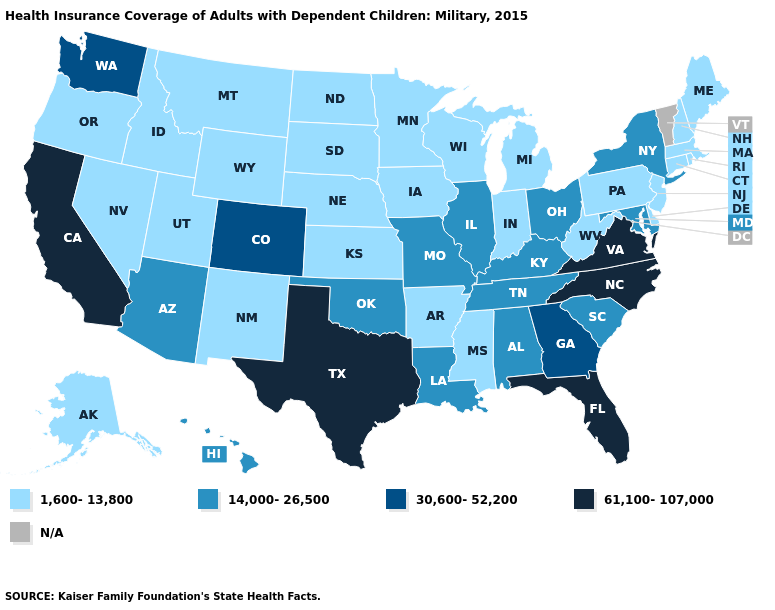Which states have the lowest value in the USA?
Be succinct. Alaska, Arkansas, Connecticut, Delaware, Idaho, Indiana, Iowa, Kansas, Maine, Massachusetts, Michigan, Minnesota, Mississippi, Montana, Nebraska, Nevada, New Hampshire, New Jersey, New Mexico, North Dakota, Oregon, Pennsylvania, Rhode Island, South Dakota, Utah, West Virginia, Wisconsin, Wyoming. Name the states that have a value in the range N/A?
Quick response, please. Vermont. Name the states that have a value in the range 30,600-52,200?
Be succinct. Colorado, Georgia, Washington. What is the value of Wisconsin?
Concise answer only. 1,600-13,800. Name the states that have a value in the range 61,100-107,000?
Give a very brief answer. California, Florida, North Carolina, Texas, Virginia. Which states have the lowest value in the MidWest?
Quick response, please. Indiana, Iowa, Kansas, Michigan, Minnesota, Nebraska, North Dakota, South Dakota, Wisconsin. What is the value of Florida?
Short answer required. 61,100-107,000. Does Texas have the highest value in the USA?
Write a very short answer. Yes. Which states have the lowest value in the South?
Short answer required. Arkansas, Delaware, Mississippi, West Virginia. Among the states that border Kentucky , which have the highest value?
Give a very brief answer. Virginia. Among the states that border Alabama , which have the lowest value?
Answer briefly. Mississippi. Which states hav the highest value in the West?
Write a very short answer. California. What is the highest value in states that border Louisiana?
Keep it brief. 61,100-107,000. How many symbols are there in the legend?
Give a very brief answer. 5. Name the states that have a value in the range 61,100-107,000?
Quick response, please. California, Florida, North Carolina, Texas, Virginia. 